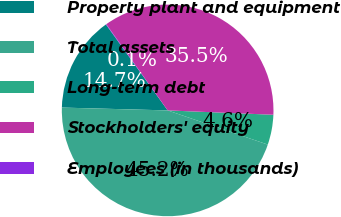Convert chart. <chart><loc_0><loc_0><loc_500><loc_500><pie_chart><fcel>Property plant and equipment<fcel>Total assets<fcel>Long-term debt<fcel>Stockholders' equity<fcel>Employees (in thousands)<nl><fcel>14.66%<fcel>45.19%<fcel>4.58%<fcel>35.5%<fcel>0.07%<nl></chart> 